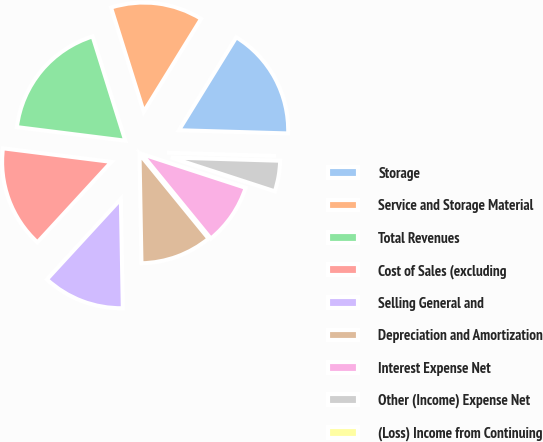Convert chart. <chart><loc_0><loc_0><loc_500><loc_500><pie_chart><fcel>Storage<fcel>Service and Storage Material<fcel>Total Revenues<fcel>Cost of Sales (excluding<fcel>Selling General and<fcel>Depreciation and Amortization<fcel>Interest Expense Net<fcel>Other (Income) Expense Net<fcel>(Loss) Income from Continuing<nl><fcel>16.67%<fcel>13.64%<fcel>18.18%<fcel>15.15%<fcel>12.12%<fcel>10.61%<fcel>9.09%<fcel>4.55%<fcel>0.0%<nl></chart> 